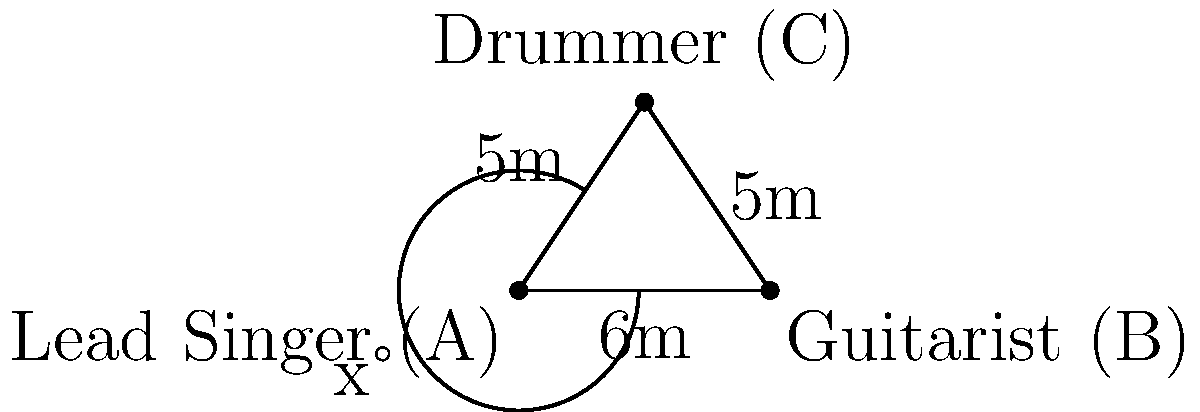In a classic rock band formation on stage, the lead singer (A), guitarist (B), and drummer (C) form a triangle. The distance between the lead singer and guitarist is 6m, while the distances from the drummer to both the lead singer and guitarist are 5m each. If the angle between the lead singer and guitarist, as seen from the drummer's position, is x°, determine the value of x to the nearest degree. Let's approach this step-by-step using the law of cosines:

1) In triangle ABC, we know:
   AB = 6m, AC = 5m, BC = 5m

2) The law of cosines states:
   $$c^2 = a^2 + b^2 - 2ab \cos(C)$$
   where C is the angle opposite side c.

3) In our case, we want to find angle C (which is x°). So we'll use:
   $$AB^2 = AC^2 + BC^2 - 2(AC)(BC) \cos(x)$$

4) Substituting the known values:
   $$6^2 = 5^2 + 5^2 - 2(5)(5) \cos(x)$$

5) Simplify:
   $$36 = 25 + 25 - 50 \cos(x)$$
   $$36 = 50 - 50 \cos(x)$$

6) Subtract 50 from both sides:
   $$-14 = -50 \cos(x)$$

7) Divide both sides by -50:
   $$\frac{14}{50} = \cos(x)$$

8) Take the inverse cosine (arccos) of both sides:
   $$x = \arccos(\frac{14}{50})$$

9) Calculate:
   $$x \approx 73.74°$$

10) Rounding to the nearest degree:
    $$x \approx 74°$$
Answer: 74° 